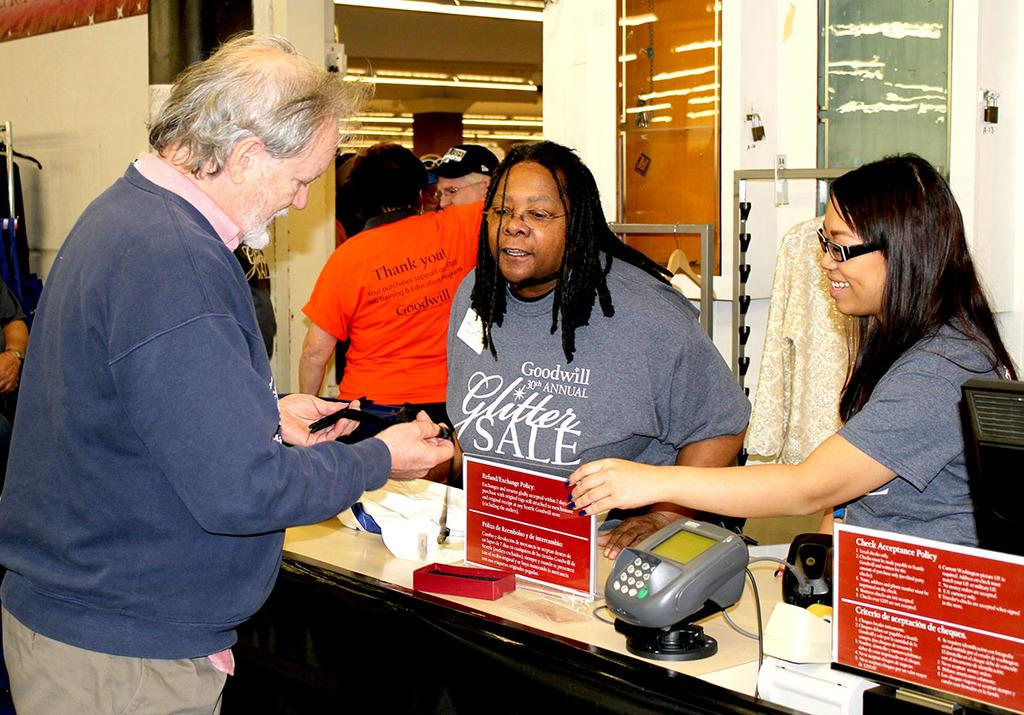How many people are visible in the image? There are many people standing in the image. Can you describe any objects or structures in the image? There is a machine on a table on the right side of the image. What type of boats can be seen in the image? There are no boats present in the image. What kind of art is displayed on the walls in the image? There is no art displayed on the walls in the image. 